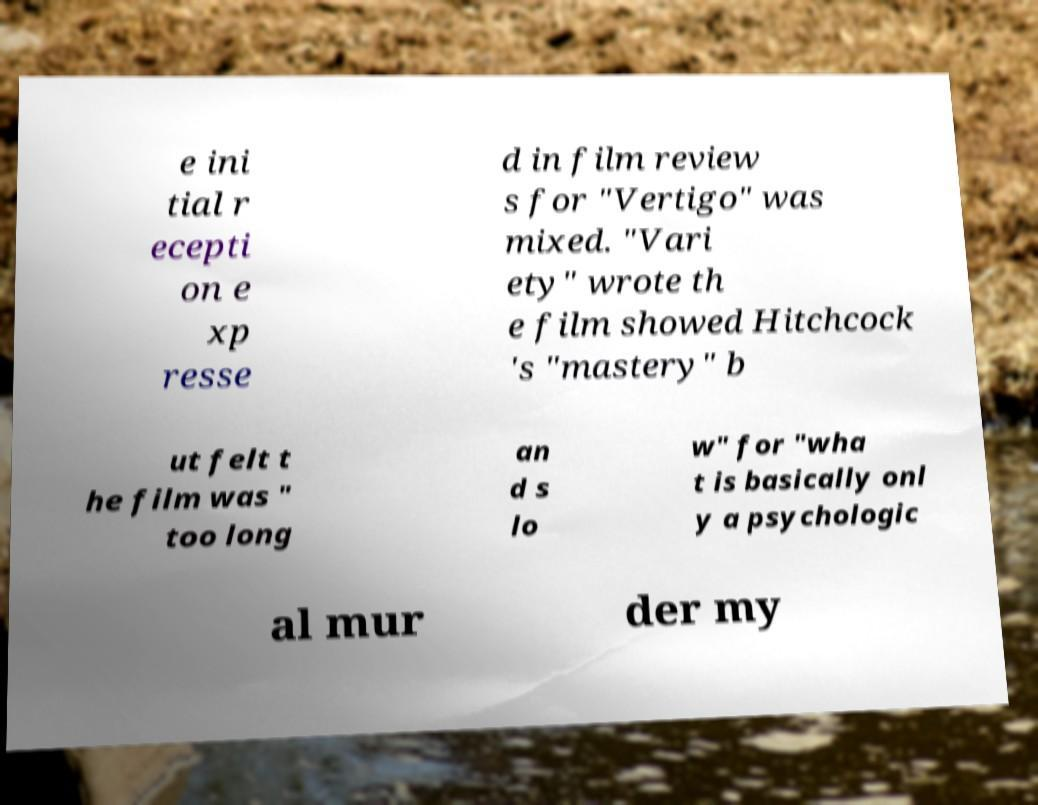Can you accurately transcribe the text from the provided image for me? e ini tial r ecepti on e xp resse d in film review s for "Vertigo" was mixed. "Vari ety" wrote th e film showed Hitchcock 's "mastery" b ut felt t he film was " too long an d s lo w" for "wha t is basically onl y a psychologic al mur der my 